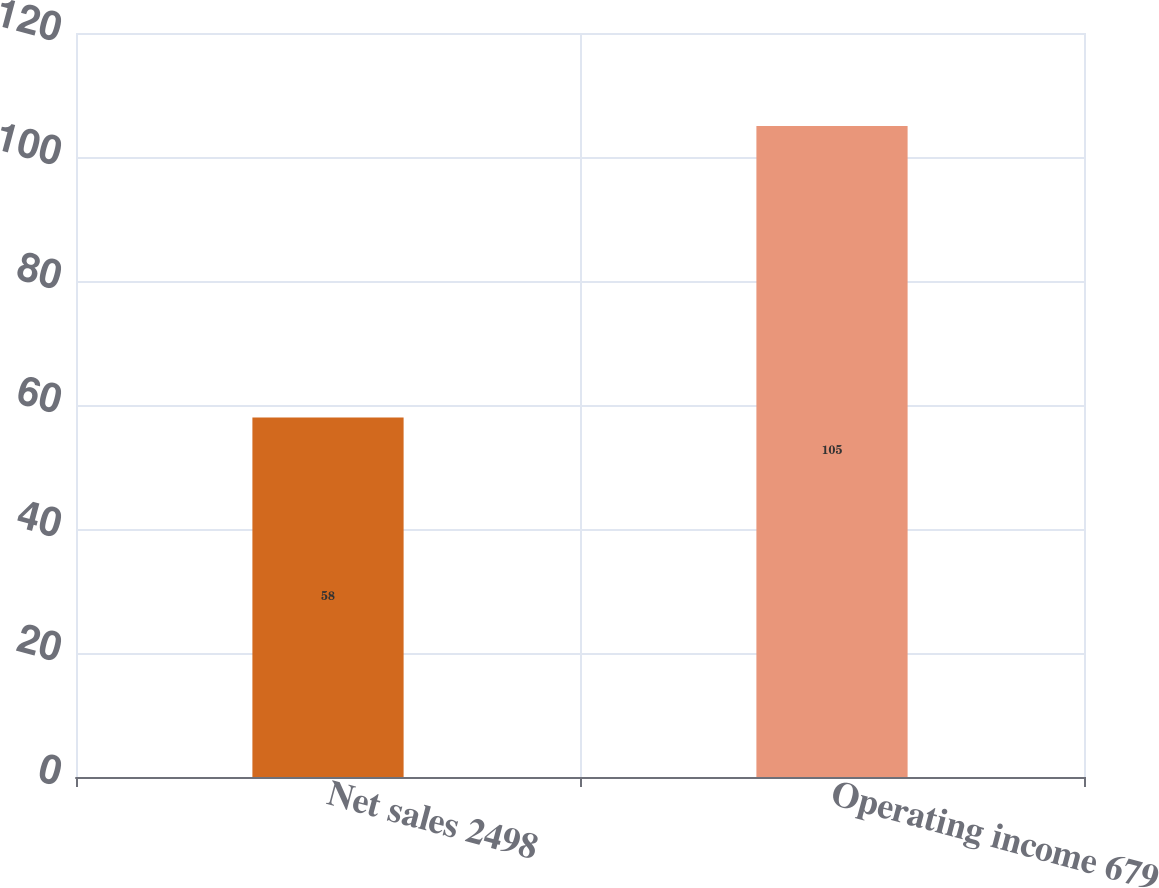Convert chart to OTSL. <chart><loc_0><loc_0><loc_500><loc_500><bar_chart><fcel>Net sales 2498<fcel>Operating income 679<nl><fcel>58<fcel>105<nl></chart> 